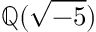Convert formula to latex. <formula><loc_0><loc_0><loc_500><loc_500>\mathbb { Q } ( { \sqrt { - 5 } } )</formula> 